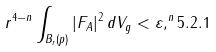Convert formula to latex. <formula><loc_0><loc_0><loc_500><loc_500>r ^ { 4 - n } \int _ { B _ { r } ( p ) } | F _ { A } | ^ { 2 } \, d V _ { g } < \varepsilon , ^ { n } { 5 . 2 . 1 }</formula> 